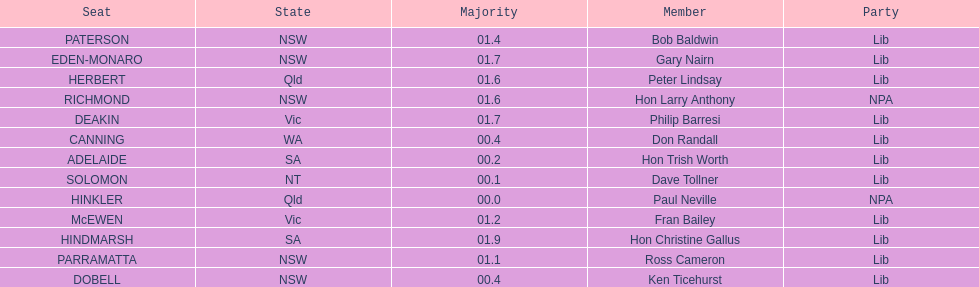How many states were represented in the seats? 6. 